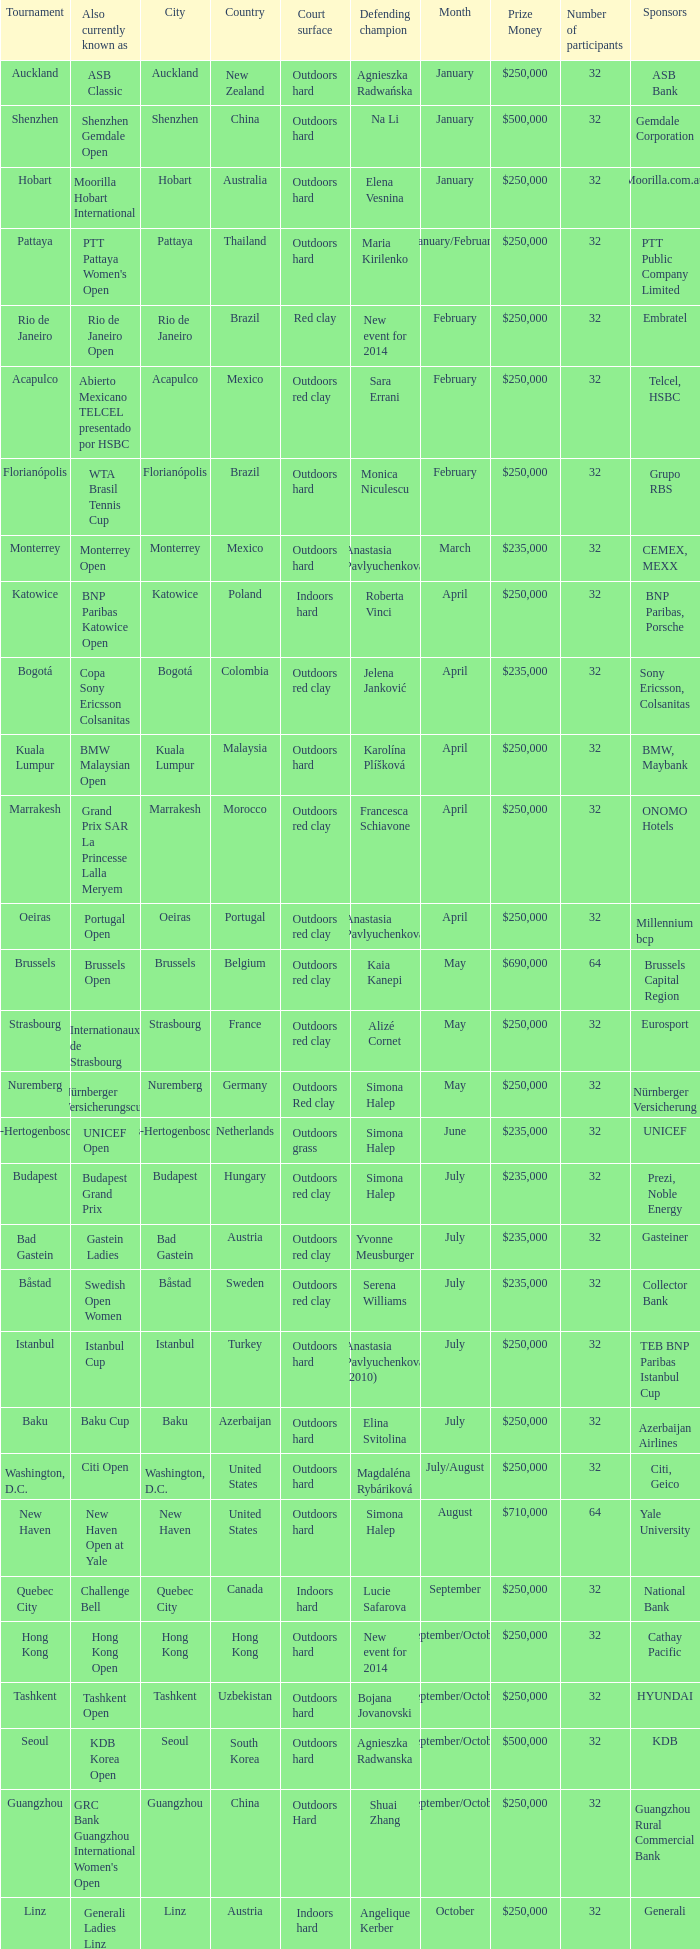How many tournaments are also currently known as the hp open? 1.0. 